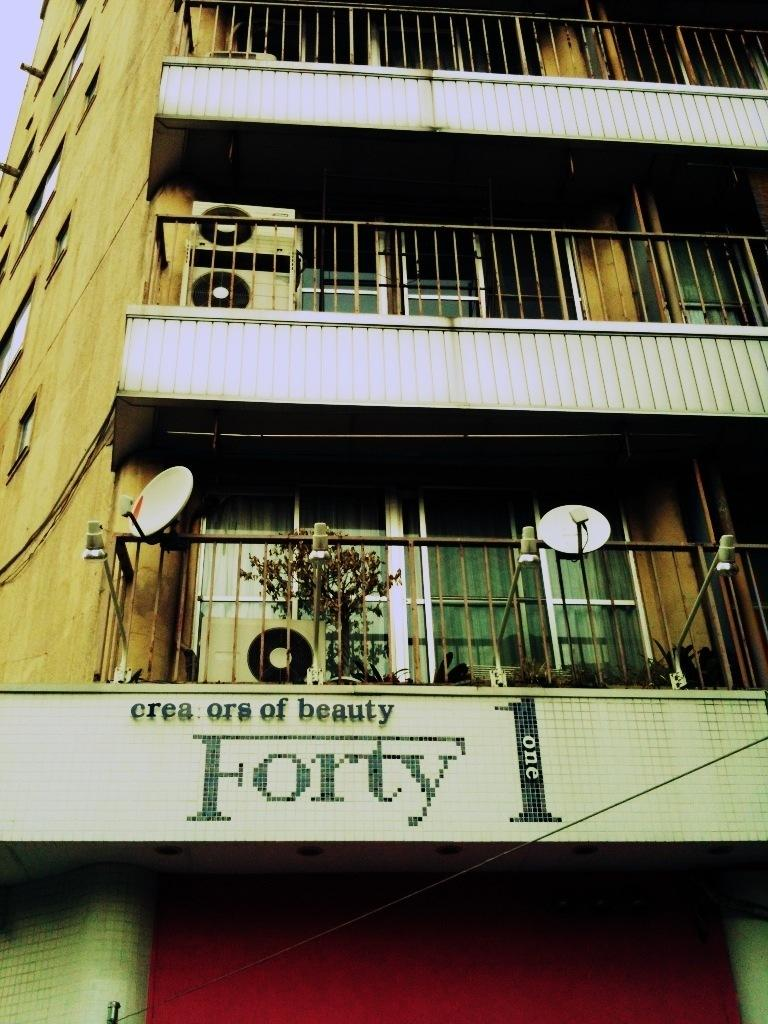What type of structure is depicted in the image? There is a multi-storey building in the image. What feature can be seen at each floor of the building? There is fencing at each floor of the building. What number is displayed at the bottom of the building? The number "FORTY" is displayed at the bottom of the building. What journey did the friends take to reach the agreement mentioned in the image? There is no mention of a journey, friends, or agreement in the image. 